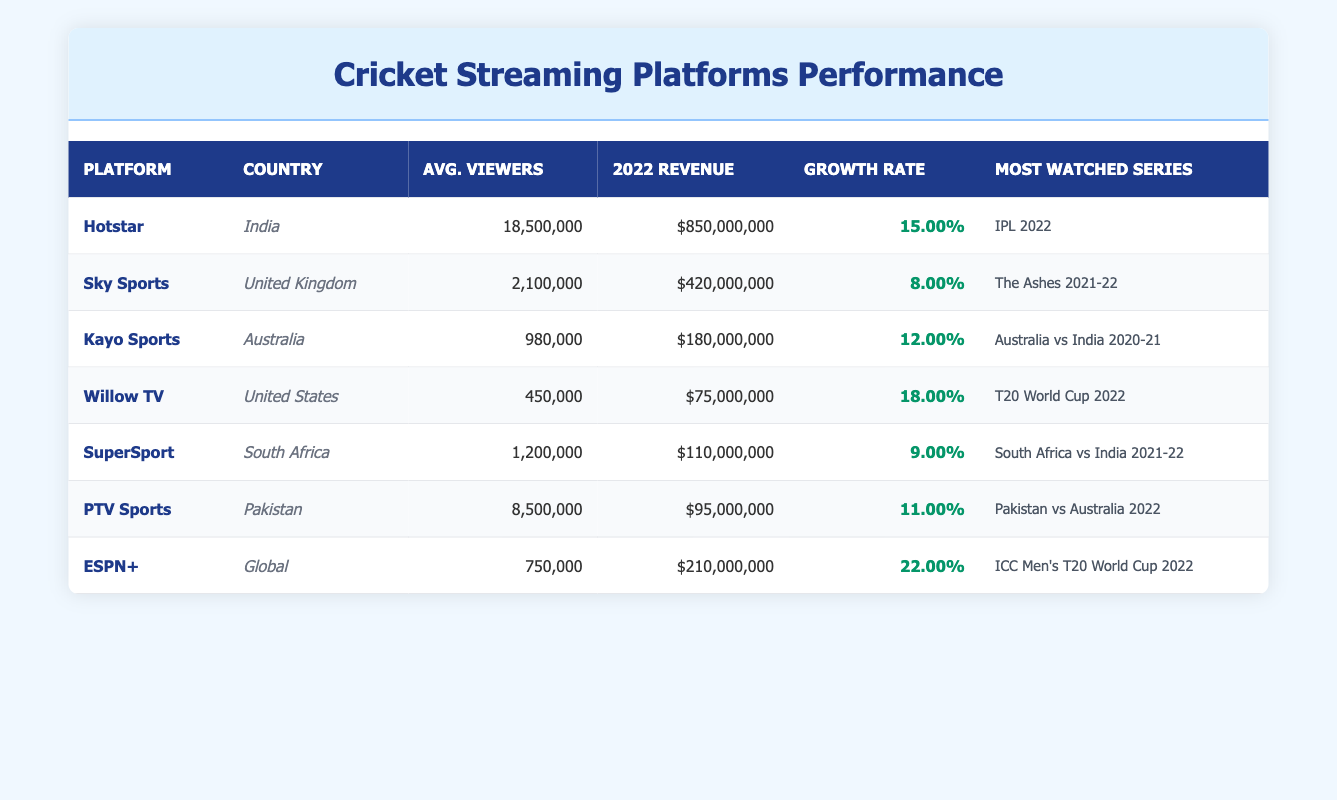What is the average number of viewers per match for Hotstar? The table lists Hotstar's average viewers per match as 18,500,000. This information is directly retrievable from the table without any calculations needed.
Answer: 18,500,000 Which platform had the highest subscription revenue in 2022? By looking at the subscription revenue for each platform, Hotstar shows the highest revenue of $850,000,000 in 2022. This information can be easily checked against the values in the relevant column.
Answer: Hotstar Calculate the total subscription revenue for cricket streaming platforms in the table. To find the total revenue, we sum the subscription revenue for all platforms: 850,000,000 + 420,000,000 + 180,000,000 + 75,000,000 + 110,000,000 + 95,000,000 + 210,000,000 = 1,640,000,000. Performing this addition step-by-step confirms the total.
Answer: 1,640,000,000 Did any platform show a growth rate of more than 20% in 2022? Examining the growth rates listed, ESPN+ has a growth rate of 22%, which is indeed greater than 20%. Other platforms have lower rates, making this a yes answer.
Answer: Yes Which country had the second highest average viewers per match? By comparing the average viewer counts from the table: Hotstar (18,500,000), Sky Sports (2,100,000), PTV Sports (8,500,000), Kayo Sports (980,000), etc., we see that after Hotstar, PTV Sports has the next highest average viewers per match. Therefore, it ranks second.
Answer: Pakistan What is the growth rate of Kayo Sports? The growth rate for Kayo Sports is listed as 12.00%. This information can be directly found in the growth rate column associated with Kayo Sports in the table.
Answer: 12.00% How much higher is Hotstar's subscription revenue than Sky Sports'? Hotstar's revenue is $850,000,000 and Sky Sports' revenue is $420,000,000. The difference is calculated as 850,000,000 - 420,000,000 = 430,000,000, indicating that Hotstar generates this much more in revenue compared to Sky Sports.
Answer: 430,000,000 Name the most watched series on ESPN+. The most watched series for ESPN+ is listed in the table as "ICC Men's T20 World Cup 2022." This is mentioned in the corresponding field for that platform.
Answer: ICC Men's T20 World Cup 2022 Is there any platform from South Africa in the table? Yes, SuperSport is shown as a platform from South Africa. This can be verified by looking at the country column and identifying the platform associated with it.
Answer: Yes Which platform has the lowest average viewers per match and what is that number? Willow TV has the lowest average viewers per match at 450,000. This can easily be confirmed by reviewing the average viewers column and identifying the lowest value present.
Answer: 450,000 